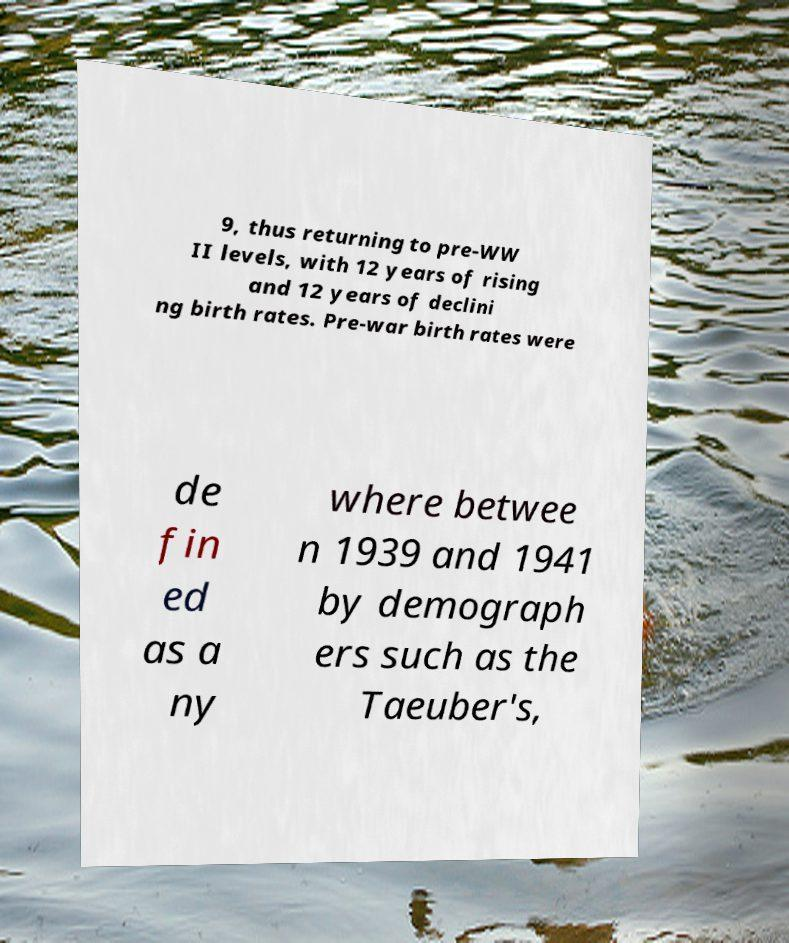Could you extract and type out the text from this image? 9, thus returning to pre-WW II levels, with 12 years of rising and 12 years of declini ng birth rates. Pre-war birth rates were de fin ed as a ny where betwee n 1939 and 1941 by demograph ers such as the Taeuber's, 